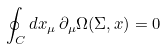Convert formula to latex. <formula><loc_0><loc_0><loc_500><loc_500>\oint _ { C } d x _ { \mu } \, \partial _ { \mu } \Omega ( \Sigma , x ) = 0</formula> 